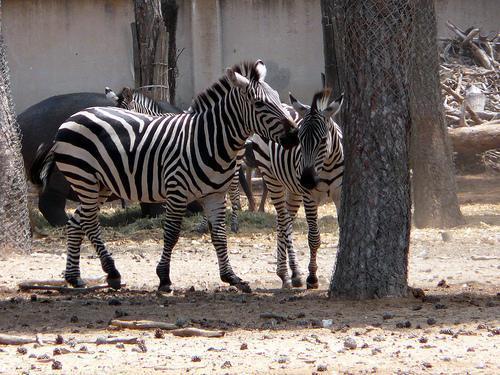How many zebras are in the picture?
Give a very brief answer. 3. 